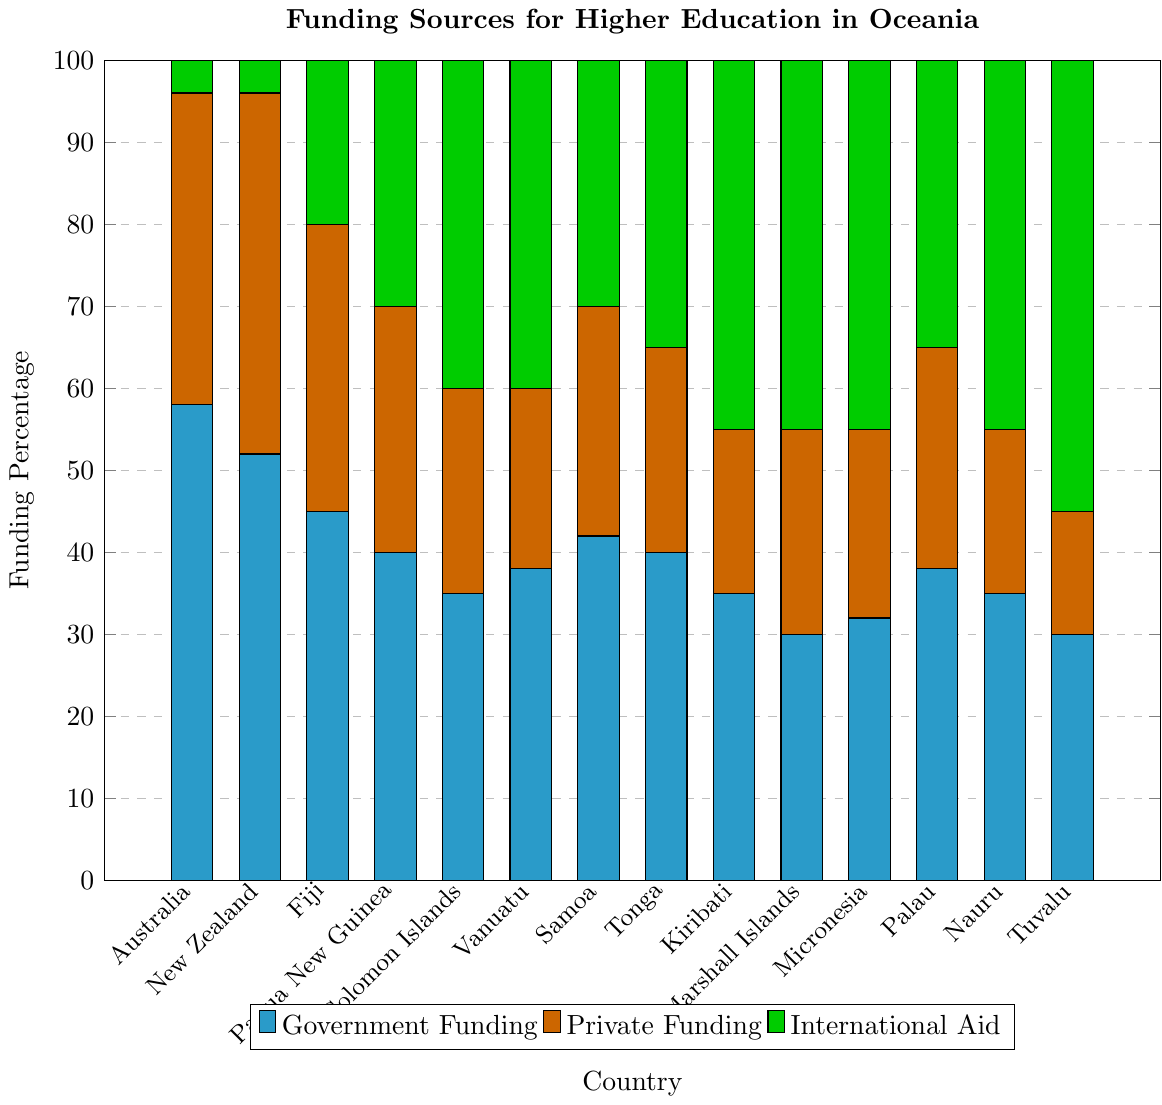Which country receives the highest percentage of government funding? To determine the highest percentage of government funding, compare the height of the cyan bars for each country. The tallest cyan bar indicates the highest percentage of government funding.
Answer: Australia Which country has the lowest percentage of private funding? To identify the lowest percentage of private funding, look for the shortest orange bar in the chart.
Answer: Tuvalu Which two countries have the same amount of international aid funding? To find countries with the same amount of international aid funding, compare the heights of the green bars. Kiribati, Marshall Islands, Micronesia, and Nauru each have the same height green bar representing 45%.
Answer: Kiribati and Marshall Islands (or Micronesia and Nauru) What is the total percentage of funding for higher education in Papua New Guinea? Sum the percentages of government, private, and international aid funding for Papua New Guinea by adding up the heights of the cyan, orange, and green bars for that country. 40% (government) + 30% (private) + 30% (international aid) = 100%.
Answer: 100% Which country has the largest portion of its funding from international aid relative to the total funding? To find this, determine the country with the green bar taking up the largest proportion of its total bar. The country with the green bar covering the most significant part of the bar is Tuvalu.
Answer: Tuvalu How many countries receive less than 40% of their funding from government sources? Count the number of countries for which the cyan bar is below the 40% mark. These countries are Solomon Islands, Kiribati, Marshall Islands, Micronesia, Nauru, and Tuvalu.
Answer: Six Compare the percentage of private funding between Australia and New Zealand. Which one is higher? Compare the height of the orange bars for Australia and New Zealand. New Zealand's orange bar is higher than Australia's, indicating a higher percentage of private funding.
Answer: New Zealand Which funding source contributes equally to Tonga's higher education as it does for Micronesia's? Look for funding categories (cyan, orange, green bars) that are of equal height for both countries. Both have 35% from international aid (green bars).
Answer: International Aid Calculate the average percentage of government funding across all countries shown. Sum all the cyan bars representing government funding and divide by the number of countries (total 14). (58 + 52 + 45 + 40 + 35 + 38 + 42 + 40 + 35 + 30 + 32 + 38 + 35 + 30) / 14 = 39.57%.
Answer: 39.57% Which country has the most balanced funding distribution among the three sources? Identify the country where the heights of the cyan, orange, and green bars are most similar. Samoa, with 42% (government), 28% (private), and 30% (international aid), has bars of nearly similar height.
Answer: Samoa 